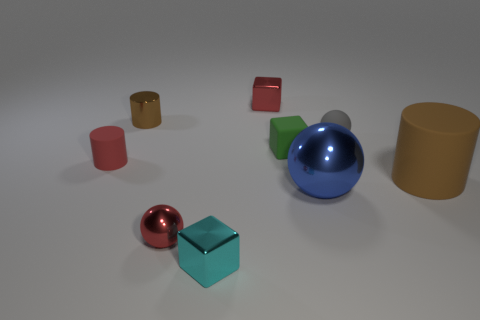Subtract all rubber cylinders. How many cylinders are left? 1 Subtract all cylinders. How many objects are left? 6 Subtract all cyan cubes. How many cubes are left? 2 Subtract all green cylinders. How many green blocks are left? 1 Subtract all small cyan matte spheres. Subtract all blue objects. How many objects are left? 8 Add 6 small rubber spheres. How many small rubber spheres are left? 7 Add 1 large cyan spheres. How many large cyan spheres exist? 1 Subtract 0 green cylinders. How many objects are left? 9 Subtract 1 cylinders. How many cylinders are left? 2 Subtract all purple cylinders. Subtract all yellow cubes. How many cylinders are left? 3 